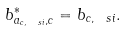Convert formula to latex. <formula><loc_0><loc_0><loc_500><loc_500>b ^ { * } _ { a _ { c , \ s i } , c } = b _ { c , \ s i } .</formula> 